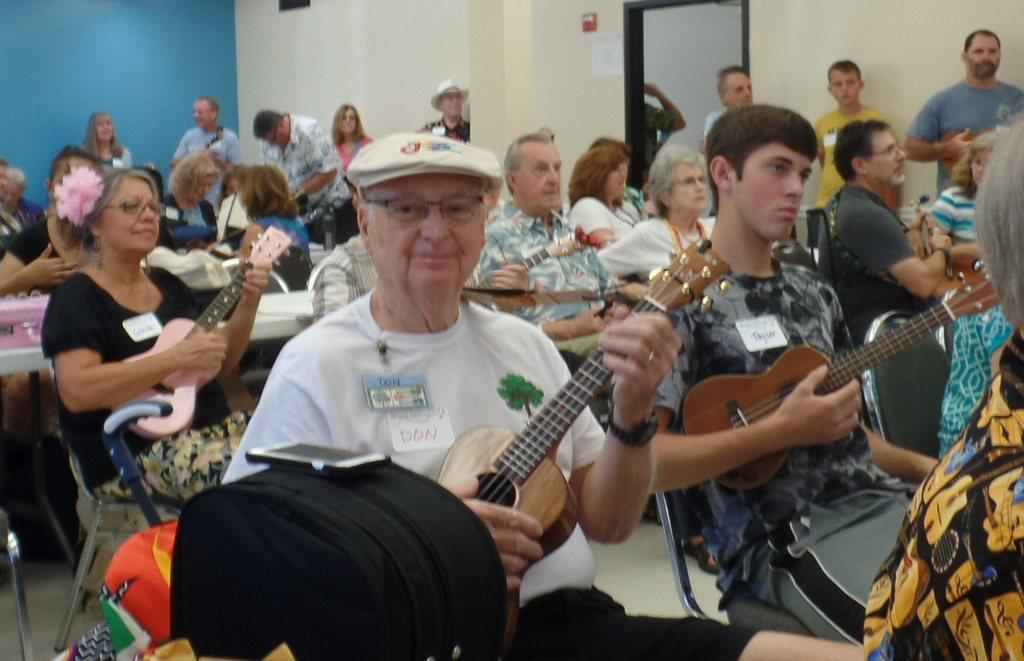What are the people in the image doing? The people are sitting on chairs and playing guitars. Are there any other people in the image? Yes, there are people standing near a wall. What can be seen on the right side of the image? There is a door on the right side of the image. What type of dirt can be seen on the floor in the image? There is no dirt visible on the floor in the image. How does the behavior of the people in the image change after the addition of a new instrument? There is no mention of an additional instrument in the image, so we cannot determine how the behavior of the people would change. 